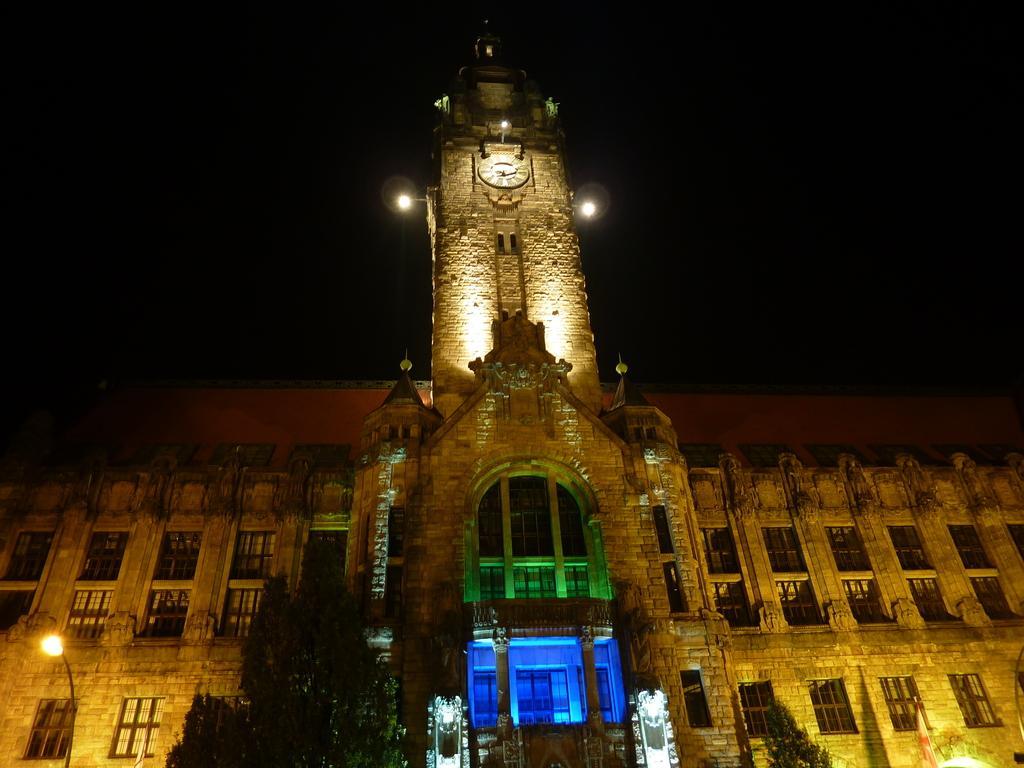In one or two sentences, can you explain what this image depicts? There are trees, a lamp pole and a building in the foreground area of the image. 